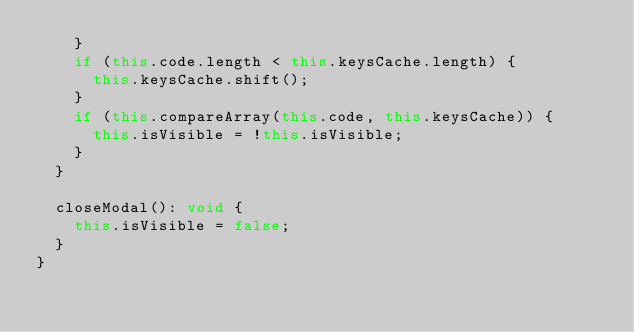Convert code to text. <code><loc_0><loc_0><loc_500><loc_500><_TypeScript_>    }
    if (this.code.length < this.keysCache.length) {
      this.keysCache.shift();
    }
    if (this.compareArray(this.code, this.keysCache)) {
      this.isVisible = !this.isVisible;
    }
  }

  closeModal(): void {
    this.isVisible = false;
  }
}
</code> 